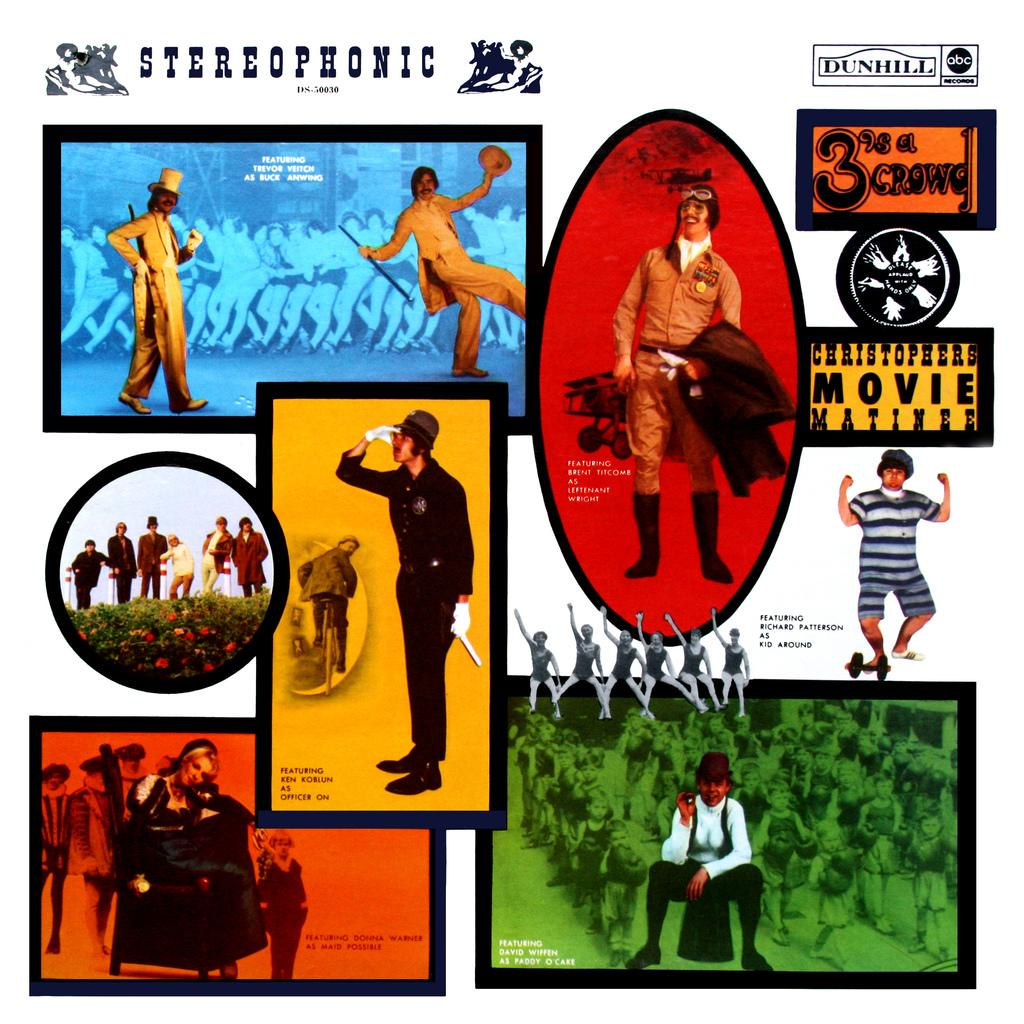What can be seen in the image that resembles a vertical structure? There are posts in the image. What is depicted on the posts? There are persons depicted on the posters. What type of cloud is present in the image? There is no cloud present in the image; it only features posts with persons depicted on them. What thoughts are being expressed by the persons on the posters? The image does not provide any information about the thoughts of the persons depicted on the posters. 